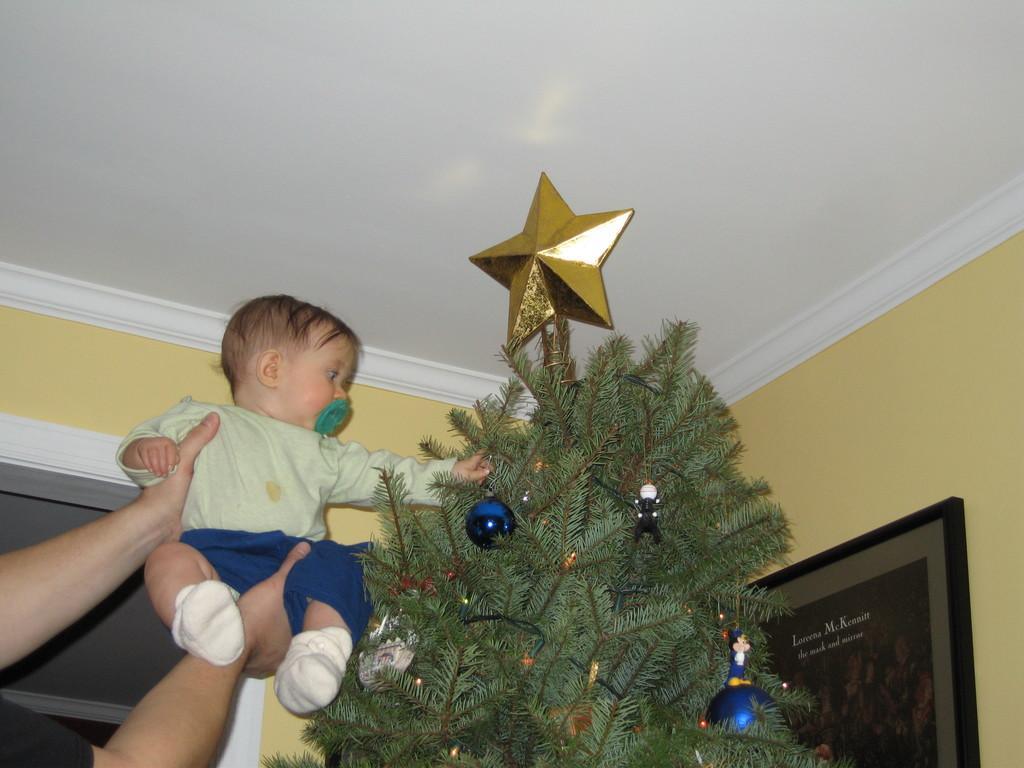Could you give a brief overview of what you see in this image? In this picture I can see the person's hand who is holding a baby boy. Beside him I can see the Christmas tree. In the bottom left corner there is a window. In the bottom right corner I can see the frame which is placed on the wall. 